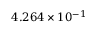Convert formula to latex. <formula><loc_0><loc_0><loc_500><loc_500>4 . 2 6 4 \times 1 0 ^ { - 1 }</formula> 